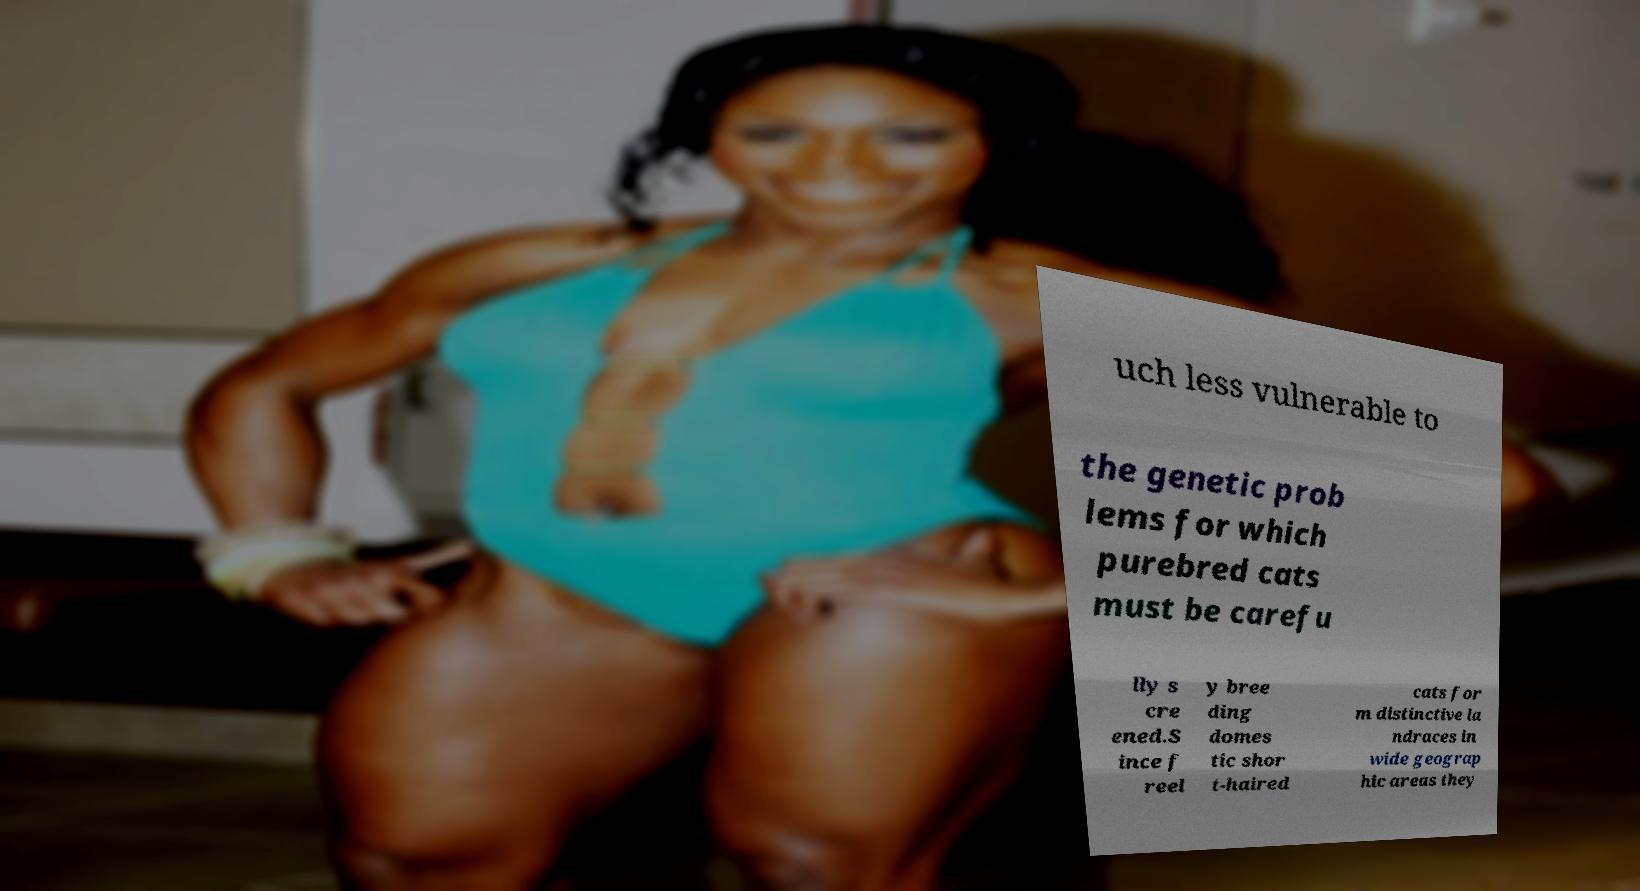What messages or text are displayed in this image? I need them in a readable, typed format. uch less vulnerable to the genetic prob lems for which purebred cats must be carefu lly s cre ened.S ince f reel y bree ding domes tic shor t-haired cats for m distinctive la ndraces in wide geograp hic areas they 